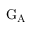Convert formula to latex. <formula><loc_0><loc_0><loc_500><loc_500>G _ { A }</formula> 